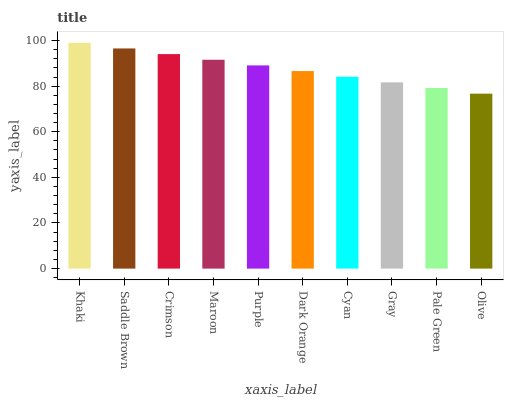Is Olive the minimum?
Answer yes or no. Yes. Is Khaki the maximum?
Answer yes or no. Yes. Is Saddle Brown the minimum?
Answer yes or no. No. Is Saddle Brown the maximum?
Answer yes or no. No. Is Khaki greater than Saddle Brown?
Answer yes or no. Yes. Is Saddle Brown less than Khaki?
Answer yes or no. Yes. Is Saddle Brown greater than Khaki?
Answer yes or no. No. Is Khaki less than Saddle Brown?
Answer yes or no. No. Is Purple the high median?
Answer yes or no. Yes. Is Dark Orange the low median?
Answer yes or no. Yes. Is Khaki the high median?
Answer yes or no. No. Is Saddle Brown the low median?
Answer yes or no. No. 